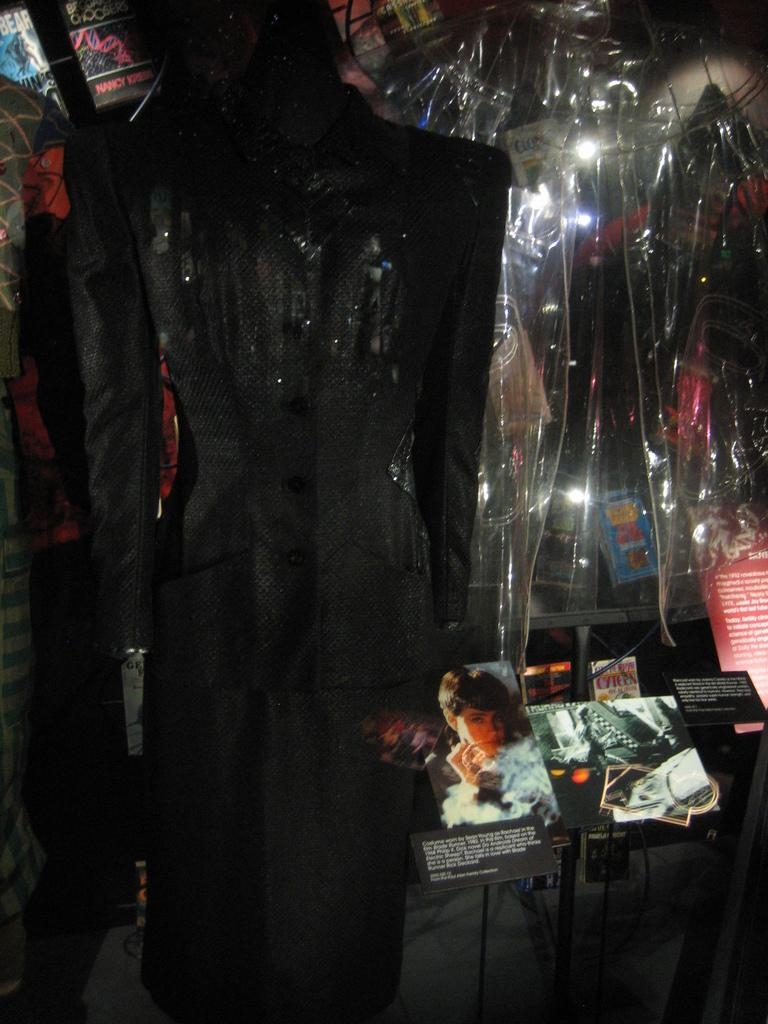What are the statues wearing in the image? The statues are wearing suits in the image. What can be seen on the rack in the image? There are books on a rack in the image. What is covering the top of the image? There are plastic covers visible at the top of the image. Who is the owner of the tent in the image? There is no tent present in the image. 